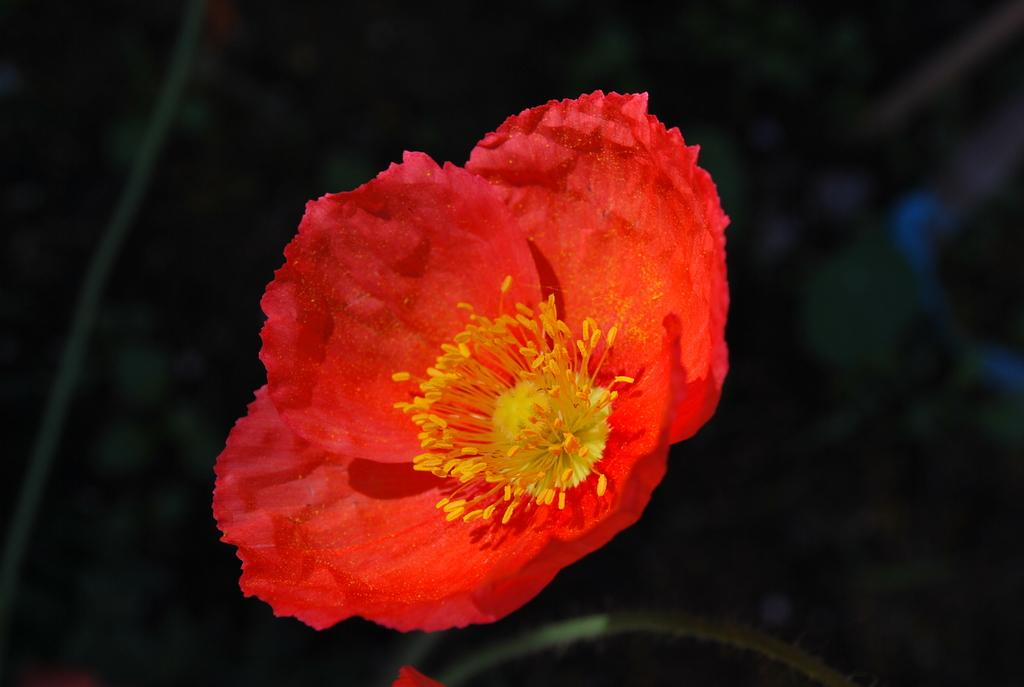What is the main subject of the image? There is a flower in the image. What colors are present in the flower? The flower's petals are red, and its stamens are yellow. What color is the background of the image? The background of the image is black. Can you tell me how many dogs are present in the image? There are no dogs present in the image; it features a flower with red petals and yellow stamens against a black background. What type of decision can be seen being made in the image? There is no decision-making process depicted in the image; it is a close-up of a flower. 